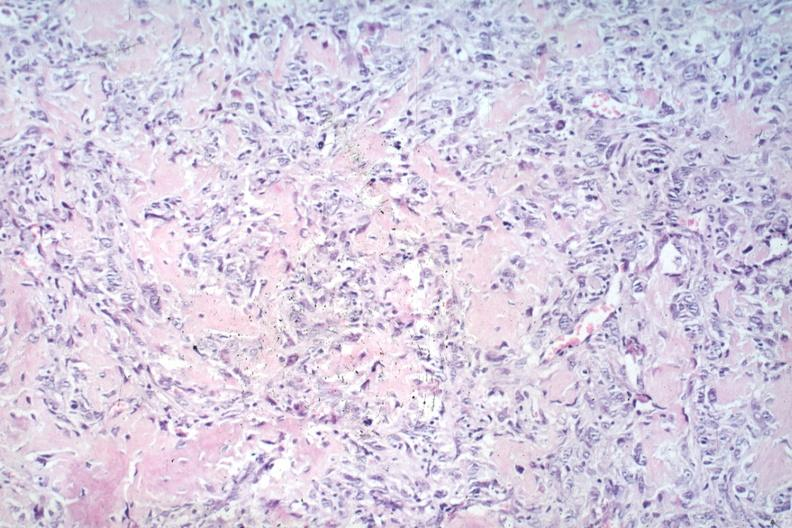does natural color show anaplastic tumor cells and osteoid?
Answer the question using a single word or phrase. No 